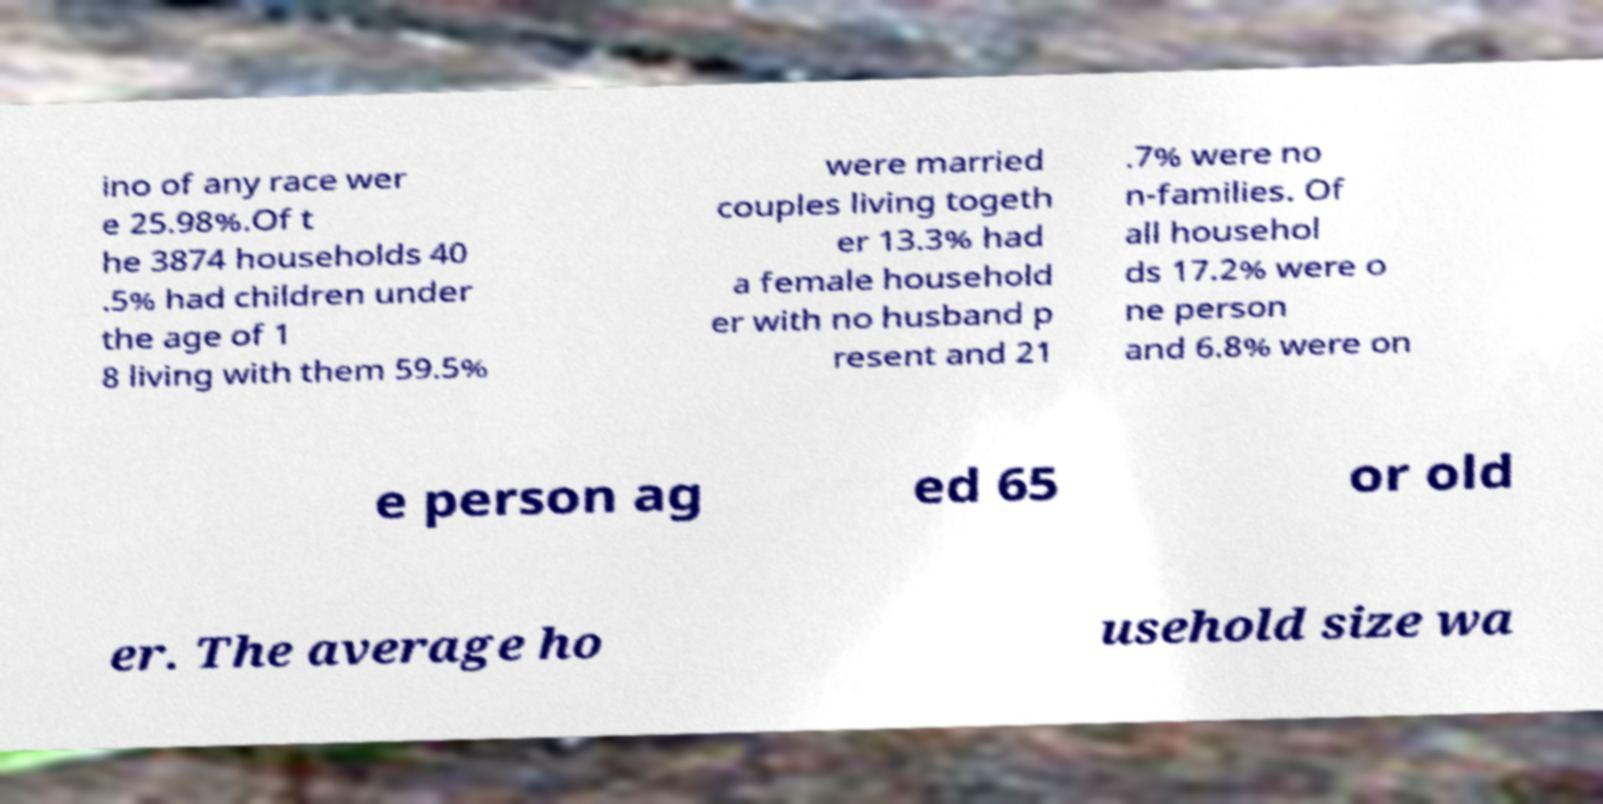Please identify and transcribe the text found in this image. ino of any race wer e 25.98%.Of t he 3874 households 40 .5% had children under the age of 1 8 living with them 59.5% were married couples living togeth er 13.3% had a female household er with no husband p resent and 21 .7% were no n-families. Of all househol ds 17.2% were o ne person and 6.8% were on e person ag ed 65 or old er. The average ho usehold size wa 